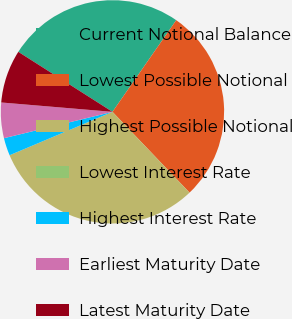Convert chart to OTSL. <chart><loc_0><loc_0><loc_500><loc_500><pie_chart><fcel>Current Notional Balance<fcel>Lowest Possible Notional<fcel>Highest Possible Notional<fcel>Lowest Interest Rate<fcel>Highest Interest Rate<fcel>Earliest Maturity Date<fcel>Latest Maturity Date<nl><fcel>25.64%<fcel>28.2%<fcel>30.77%<fcel>0.0%<fcel>2.56%<fcel>5.13%<fcel>7.69%<nl></chart> 